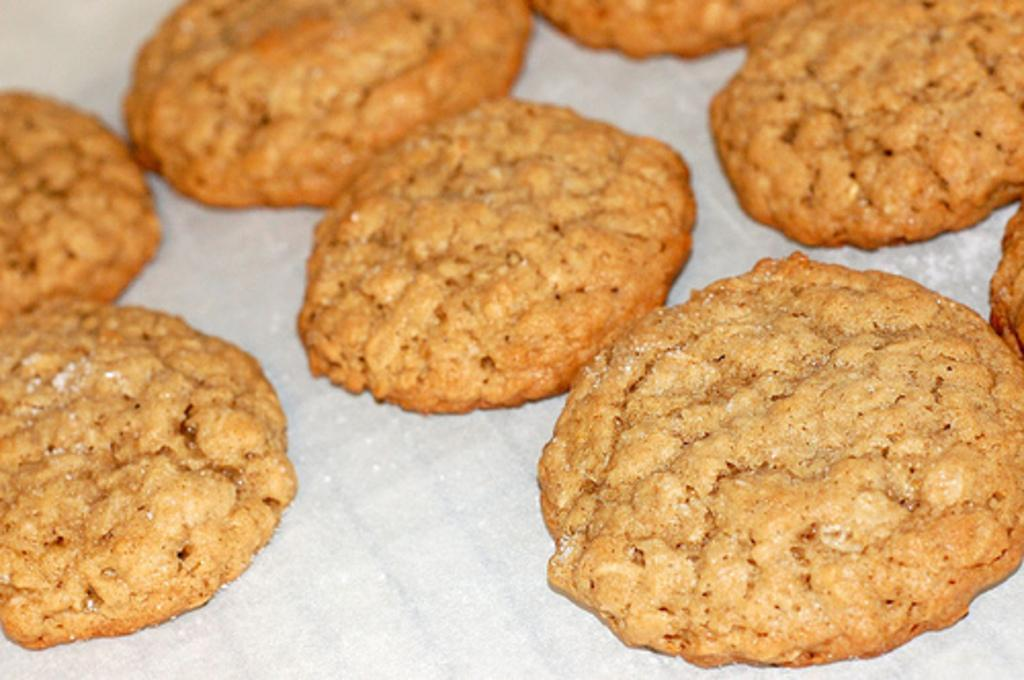What type of food is visible in the image? There are cookies in the image. What is the color of the surface on which the cookies are placed? The cookies are on a white surface. How many books are stacked on top of the cookies in the image? There are no books present in the image; it only features cookies on a white surface. 